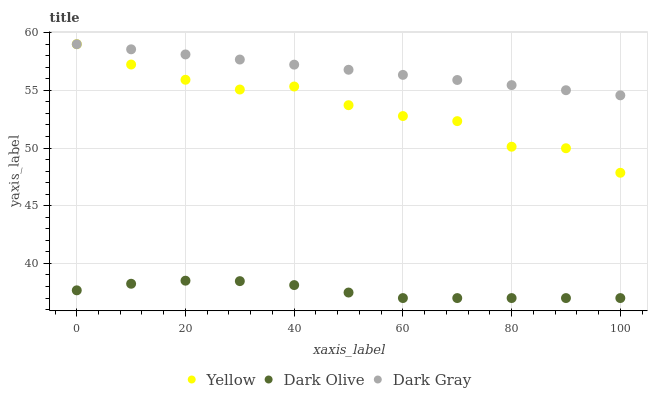Does Dark Olive have the minimum area under the curve?
Answer yes or no. Yes. Does Dark Gray have the maximum area under the curve?
Answer yes or no. Yes. Does Yellow have the minimum area under the curve?
Answer yes or no. No. Does Yellow have the maximum area under the curve?
Answer yes or no. No. Is Dark Gray the smoothest?
Answer yes or no. Yes. Is Yellow the roughest?
Answer yes or no. Yes. Is Dark Olive the smoothest?
Answer yes or no. No. Is Dark Olive the roughest?
Answer yes or no. No. Does Dark Olive have the lowest value?
Answer yes or no. Yes. Does Yellow have the lowest value?
Answer yes or no. No. Does Yellow have the highest value?
Answer yes or no. Yes. Does Dark Olive have the highest value?
Answer yes or no. No. Is Dark Olive less than Dark Gray?
Answer yes or no. Yes. Is Dark Gray greater than Dark Olive?
Answer yes or no. Yes. Does Yellow intersect Dark Gray?
Answer yes or no. Yes. Is Yellow less than Dark Gray?
Answer yes or no. No. Is Yellow greater than Dark Gray?
Answer yes or no. No. Does Dark Olive intersect Dark Gray?
Answer yes or no. No. 